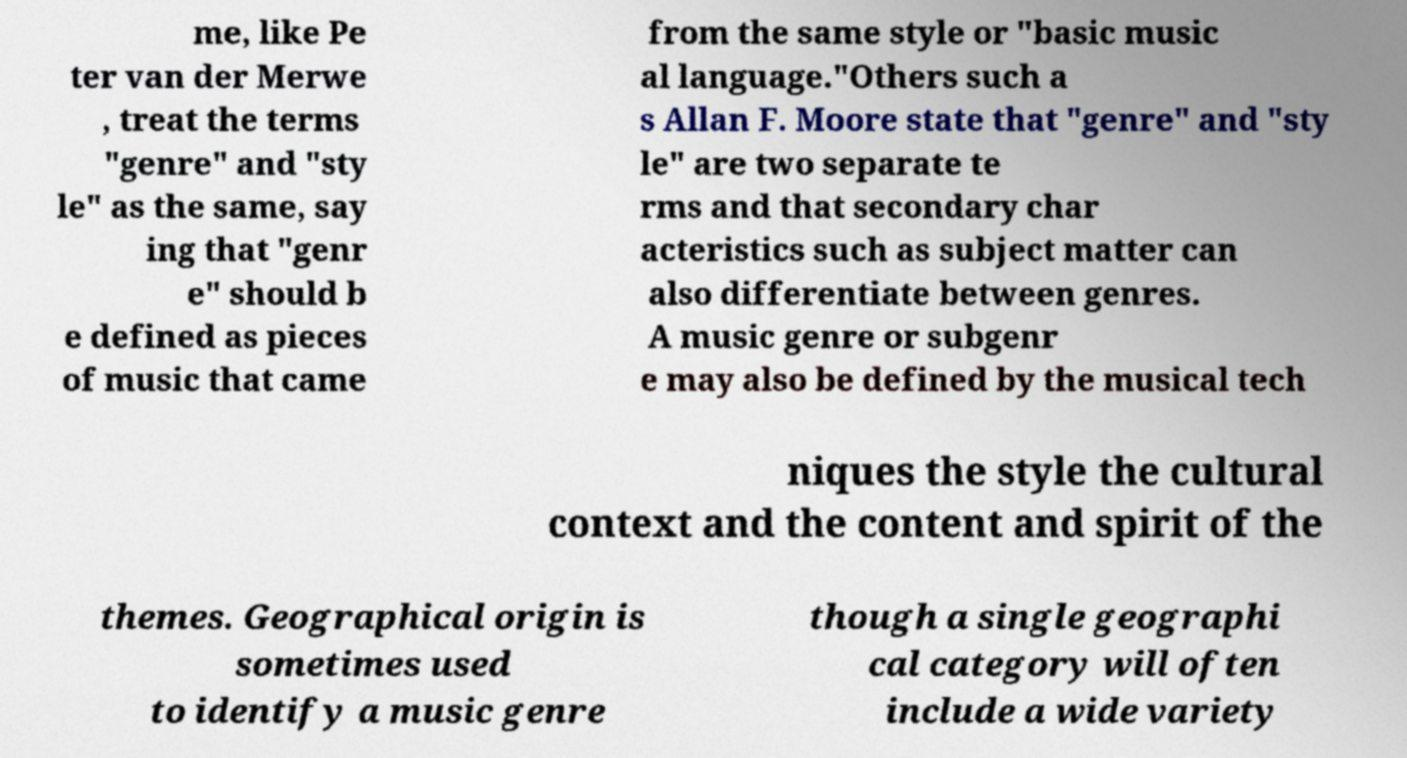Please identify and transcribe the text found in this image. me, like Pe ter van der Merwe , treat the terms "genre" and "sty le" as the same, say ing that "genr e" should b e defined as pieces of music that came from the same style or "basic music al language."Others such a s Allan F. Moore state that "genre" and "sty le" are two separate te rms and that secondary char acteristics such as subject matter can also differentiate between genres. A music genre or subgenr e may also be defined by the musical tech niques the style the cultural context and the content and spirit of the themes. Geographical origin is sometimes used to identify a music genre though a single geographi cal category will often include a wide variety 